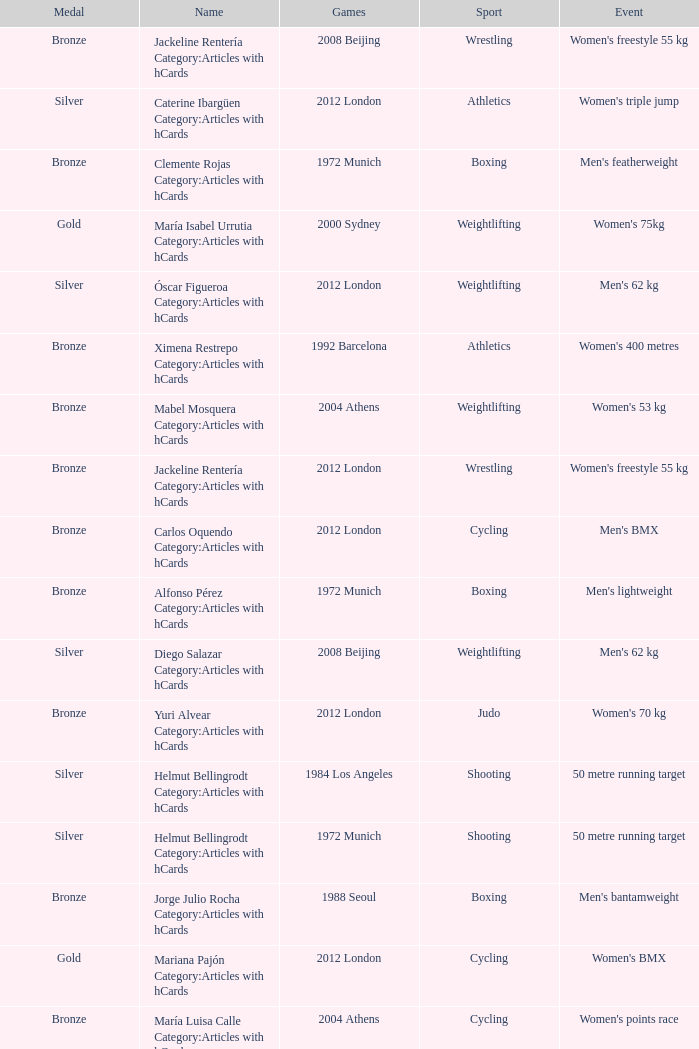Could you parse the entire table as a dict? {'header': ['Medal', 'Name', 'Games', 'Sport', 'Event'], 'rows': [['Bronze', 'Jackeline Rentería Category:Articles with hCards', '2008 Beijing', 'Wrestling', "Women's freestyle 55 kg"], ['Silver', 'Caterine Ibargüen Category:Articles with hCards', '2012 London', 'Athletics', "Women's triple jump"], ['Bronze', 'Clemente Rojas Category:Articles with hCards', '1972 Munich', 'Boxing', "Men's featherweight"], ['Gold', 'María Isabel Urrutia Category:Articles with hCards', '2000 Sydney', 'Weightlifting', "Women's 75kg"], ['Silver', 'Óscar Figueroa Category:Articles with hCards', '2012 London', 'Weightlifting', "Men's 62 kg"], ['Bronze', 'Ximena Restrepo Category:Articles with hCards', '1992 Barcelona', 'Athletics', "Women's 400 metres"], ['Bronze', 'Mabel Mosquera Category:Articles with hCards', '2004 Athens', 'Weightlifting', "Women's 53 kg"], ['Bronze', 'Jackeline Rentería Category:Articles with hCards', '2012 London', 'Wrestling', "Women's freestyle 55 kg"], ['Bronze', 'Carlos Oquendo Category:Articles with hCards', '2012 London', 'Cycling', "Men's BMX"], ['Bronze', 'Alfonso Pérez Category:Articles with hCards', '1972 Munich', 'Boxing', "Men's lightweight"], ['Silver', 'Diego Salazar Category:Articles with hCards', '2008 Beijing', 'Weightlifting', "Men's 62 kg"], ['Bronze', 'Yuri Alvear Category:Articles with hCards', '2012 London', 'Judo', "Women's 70 kg"], ['Silver', 'Helmut Bellingrodt Category:Articles with hCards', '1984 Los Angeles', 'Shooting', '50 metre running target'], ['Silver', 'Helmut Bellingrodt Category:Articles with hCards', '1972 Munich', 'Shooting', '50 metre running target'], ['Bronze', 'Jorge Julio Rocha Category:Articles with hCards', '1988 Seoul', 'Boxing', "Men's bantamweight"], ['Gold', 'Mariana Pajón Category:Articles with hCards', '2012 London', 'Cycling', "Women's BMX"], ['Bronze', 'María Luisa Calle Category:Articles with hCards', '2004 Athens', 'Cycling', "Women's points race"], ['Silver', 'Rigoberto Urán Category:Articles with hCards', '2012 London', 'Cycling', "Men's road race"], ['Bronze', 'Óscar Muñoz Oviedo Category:Articles with hCards', '2012 London', 'Taekwondo', "Men's 58 kg"]]} Which sport resulted in a gold medal in the 2000 Sydney games? Weightlifting. 